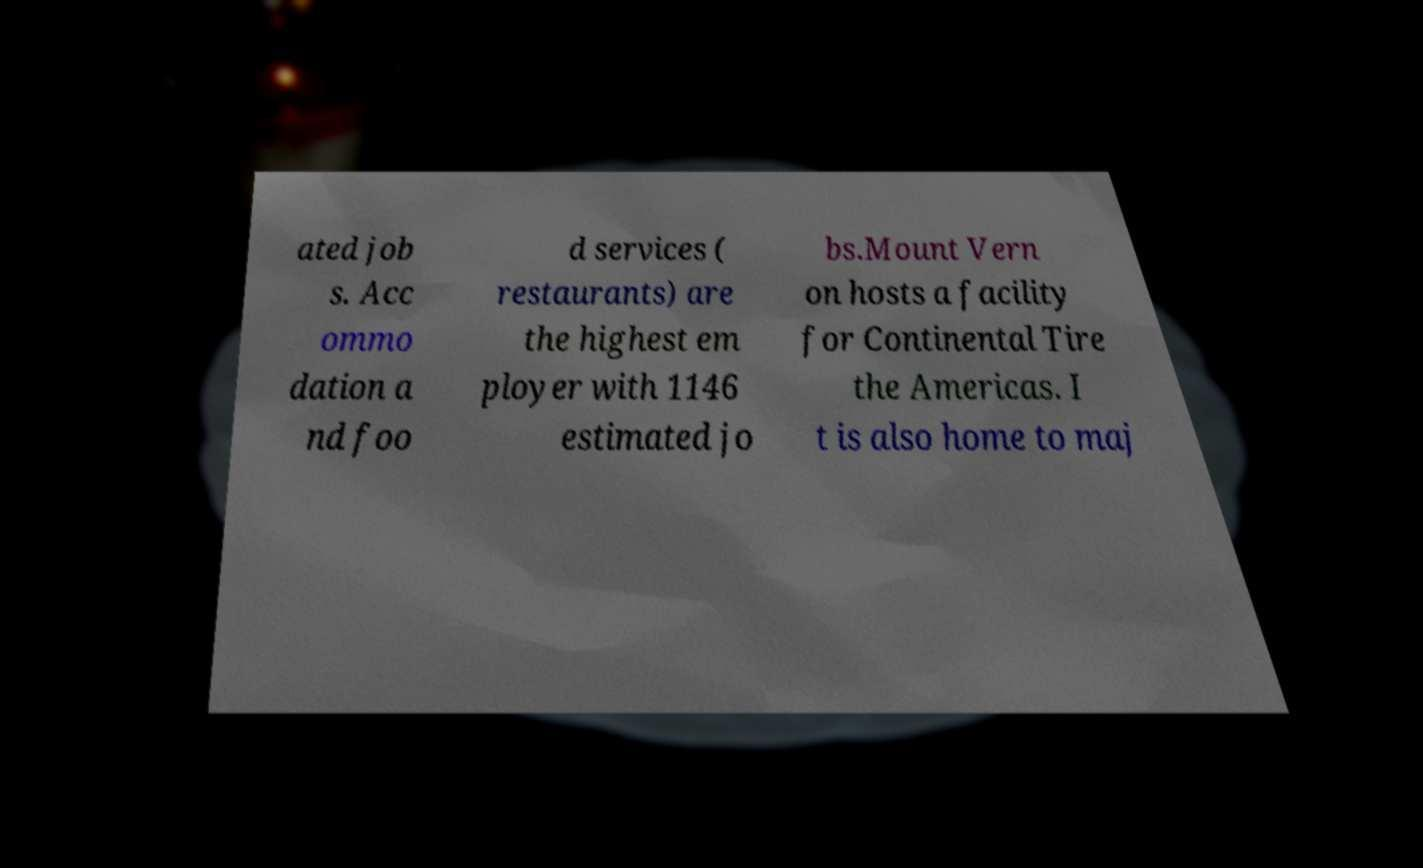Please identify and transcribe the text found in this image. ated job s. Acc ommo dation a nd foo d services ( restaurants) are the highest em ployer with 1146 estimated jo bs.Mount Vern on hosts a facility for Continental Tire the Americas. I t is also home to maj 